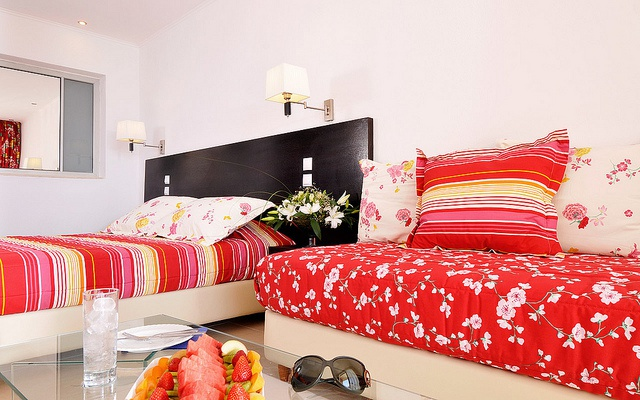Describe the objects in this image and their specific colors. I can see couch in lightgray, red, tan, and lightpink tones, bed in lightgray, white, red, salmon, and lightpink tones, potted plant in lightgray, black, olive, and tan tones, cup in lightgray, pink, and darkgray tones, and fork in lightgray and darkgray tones in this image. 